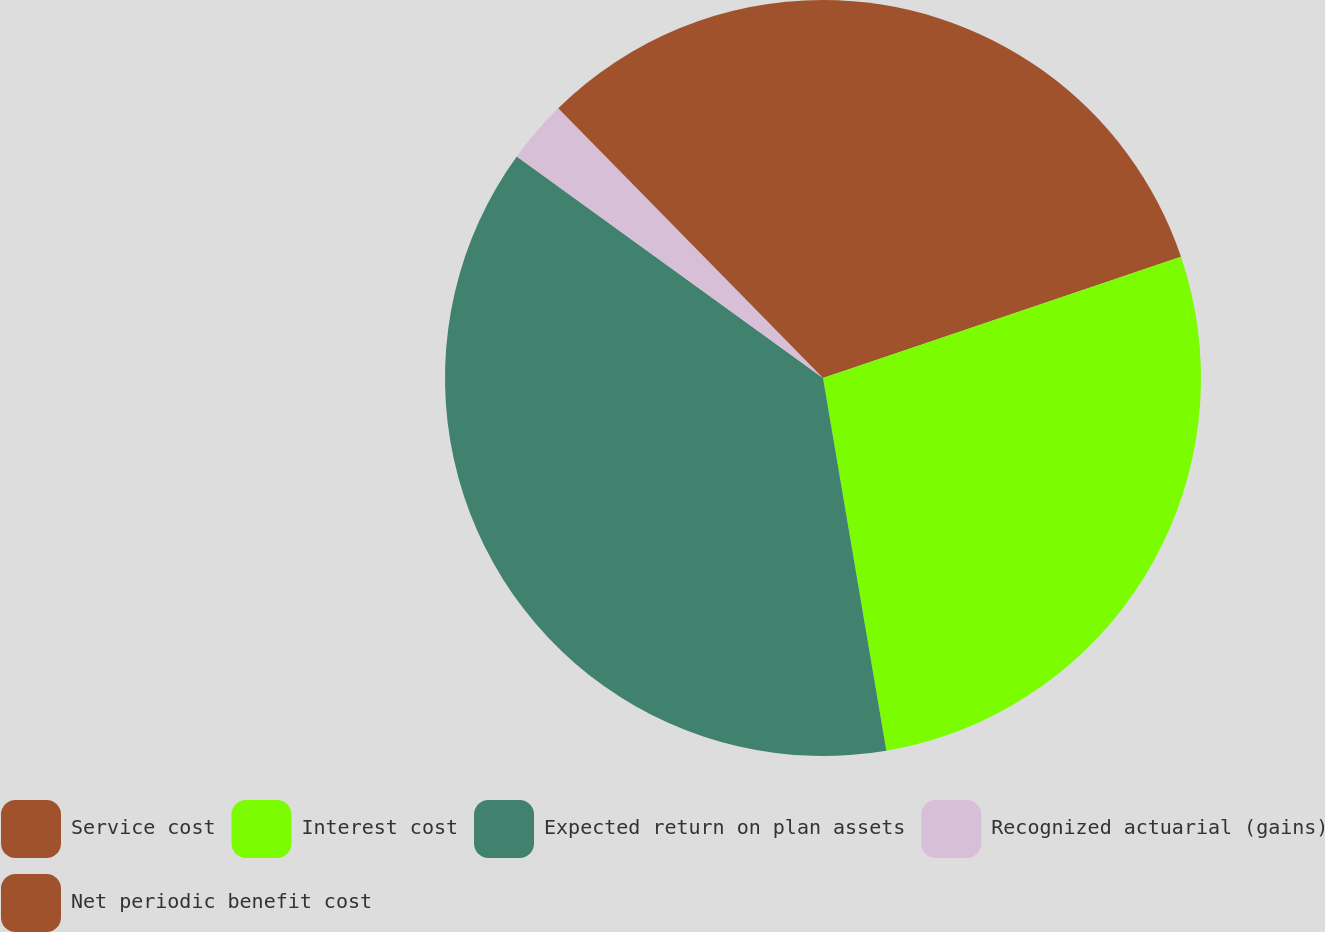Convert chart to OTSL. <chart><loc_0><loc_0><loc_500><loc_500><pie_chart><fcel>Service cost<fcel>Interest cost<fcel>Expected return on plan assets<fcel>Recognized actuarial (gains)<fcel>Net periodic benefit cost<nl><fcel>19.8%<fcel>27.52%<fcel>37.65%<fcel>2.68%<fcel>12.35%<nl></chart> 